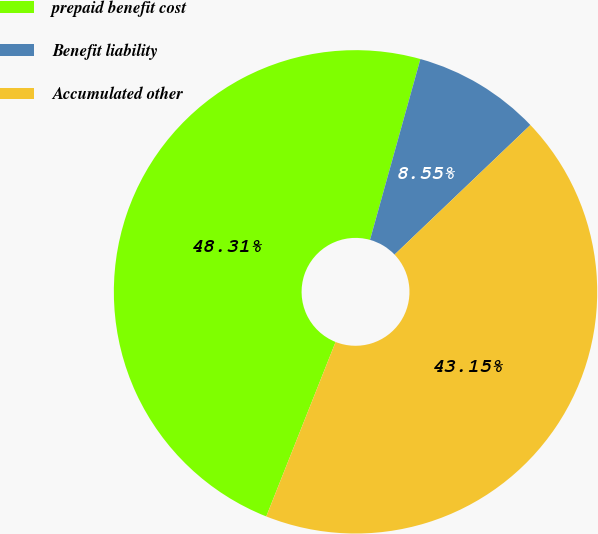Convert chart to OTSL. <chart><loc_0><loc_0><loc_500><loc_500><pie_chart><fcel>prepaid benefit cost<fcel>Benefit liability<fcel>Accumulated other<nl><fcel>48.31%<fcel>8.55%<fcel>43.15%<nl></chart> 